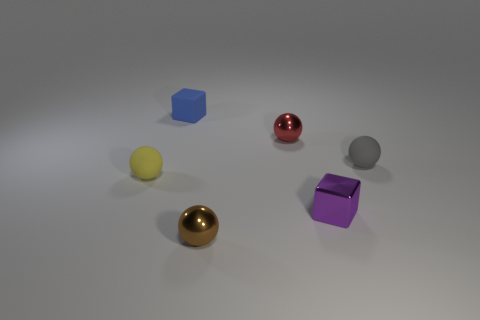What is the size of the ball that is to the right of the small metallic object that is behind the gray rubber ball?
Your response must be concise. Small. Is the thing left of the blue rubber thing made of the same material as the brown thing?
Your answer should be compact. No. There is a red object that is behind the small purple shiny block; what shape is it?
Provide a succinct answer. Sphere. How many spheres have the same size as the purple metal cube?
Offer a very short reply. 4. What size is the gray ball?
Provide a succinct answer. Small. How many red metallic things are behind the tiny blue block?
Your response must be concise. 0. The small blue object that is made of the same material as the tiny gray ball is what shape?
Your answer should be very brief. Cube. Is the number of tiny gray things to the right of the gray matte sphere less than the number of tiny brown objects that are to the left of the small brown metal ball?
Provide a succinct answer. No. Are there more tiny metal cubes than big purple spheres?
Make the answer very short. Yes. What material is the gray object?
Provide a succinct answer. Rubber. 